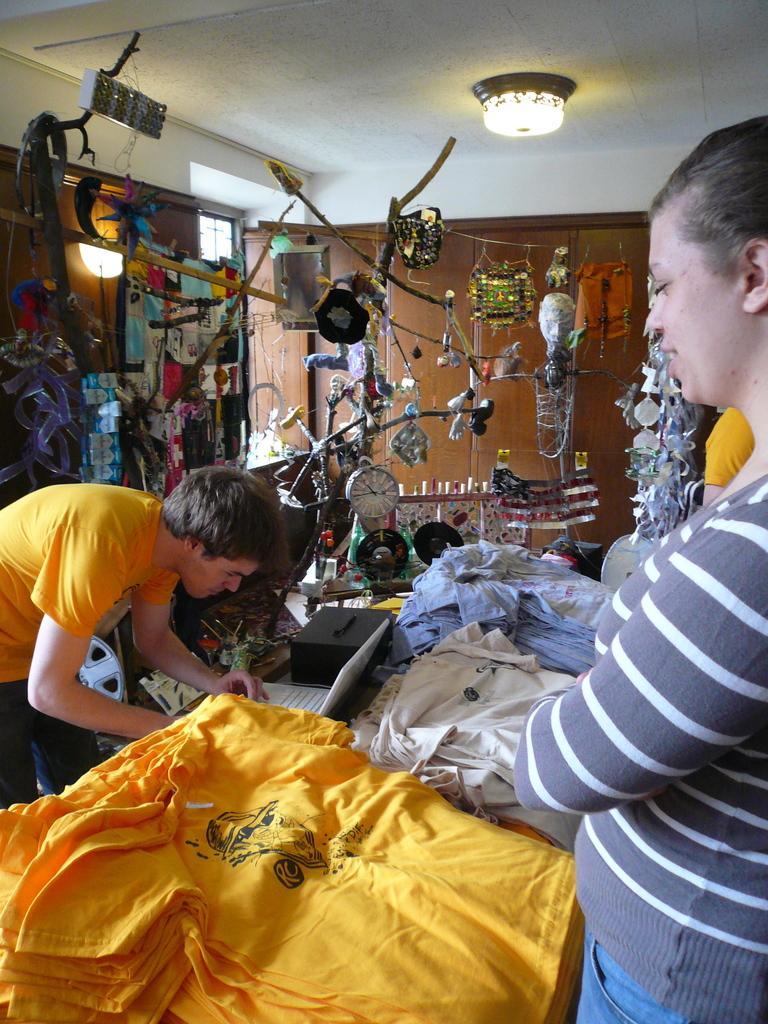Please provide a concise description of this image. In the image we can see there are people standing and wearing clothes. Here we can see clothes, clock, light and other decorative things. Here we can see a wooden door. 